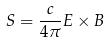<formula> <loc_0><loc_0><loc_500><loc_500>S = \frac { c } { 4 \pi } E \times B</formula> 